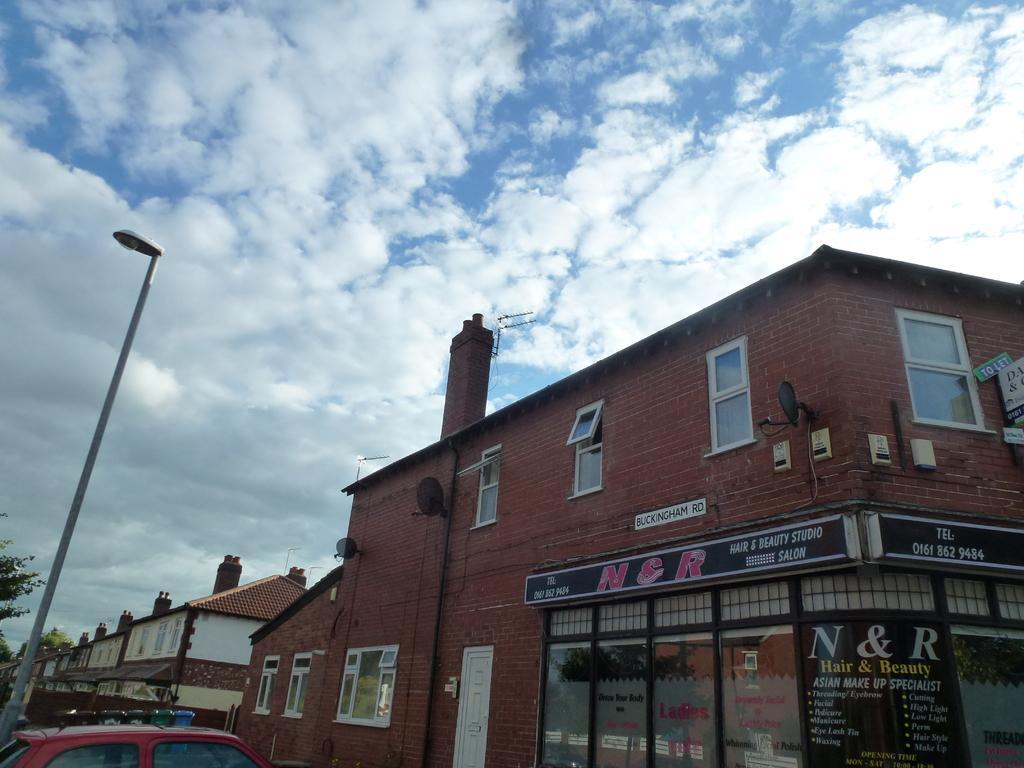Please provide a concise description of this image. In this image there are buildings and in the front on the building there is a board with some text written on it. On the left side there is a car which is red in colour and there is a pole and there is a tree and the sky is cloudy. 